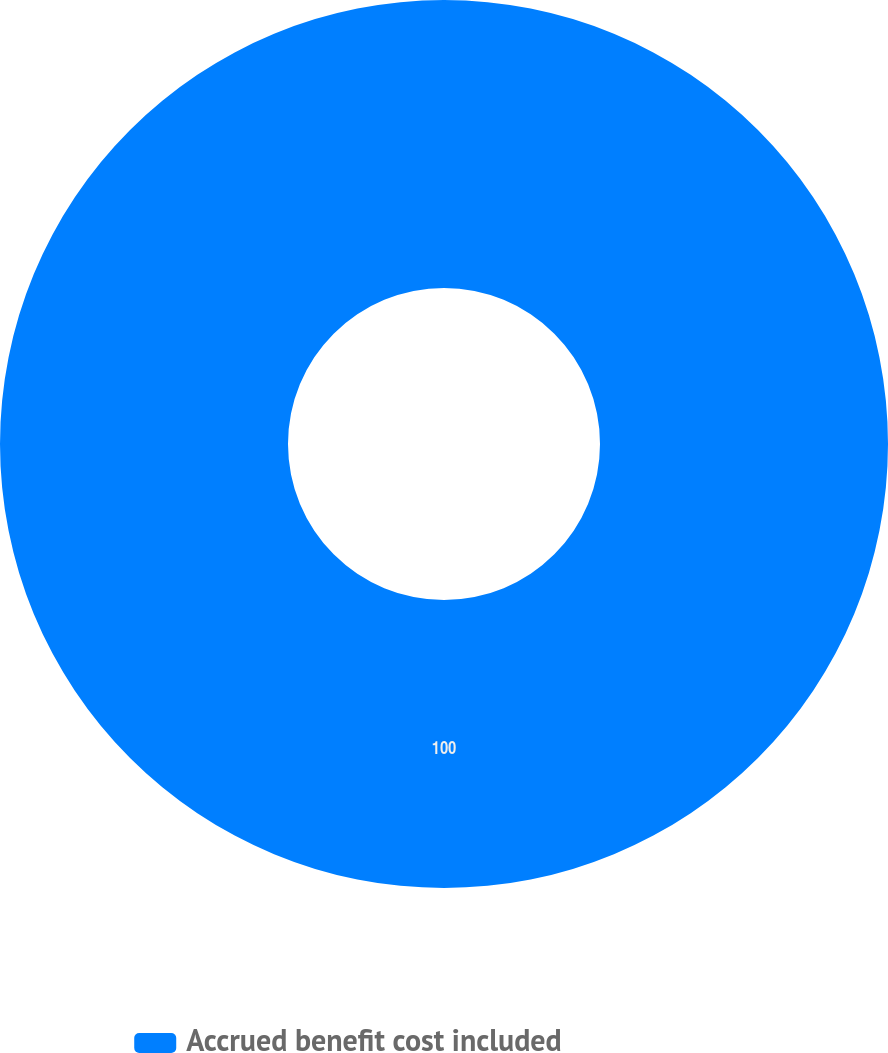Convert chart. <chart><loc_0><loc_0><loc_500><loc_500><pie_chart><fcel>Accrued benefit cost included<nl><fcel>100.0%<nl></chart> 